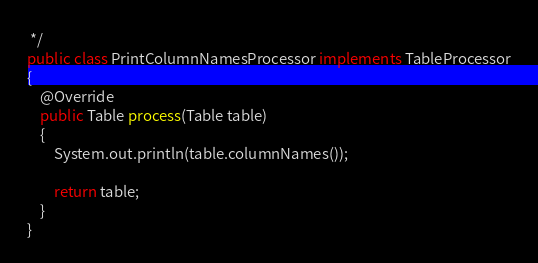Convert code to text. <code><loc_0><loc_0><loc_500><loc_500><_Java_> */
public class PrintColumnNamesProcessor implements TableProcessor
{
    @Override
    public Table process(Table table)
    {
        System.out.println(table.columnNames());

        return table;
    }
}
</code> 